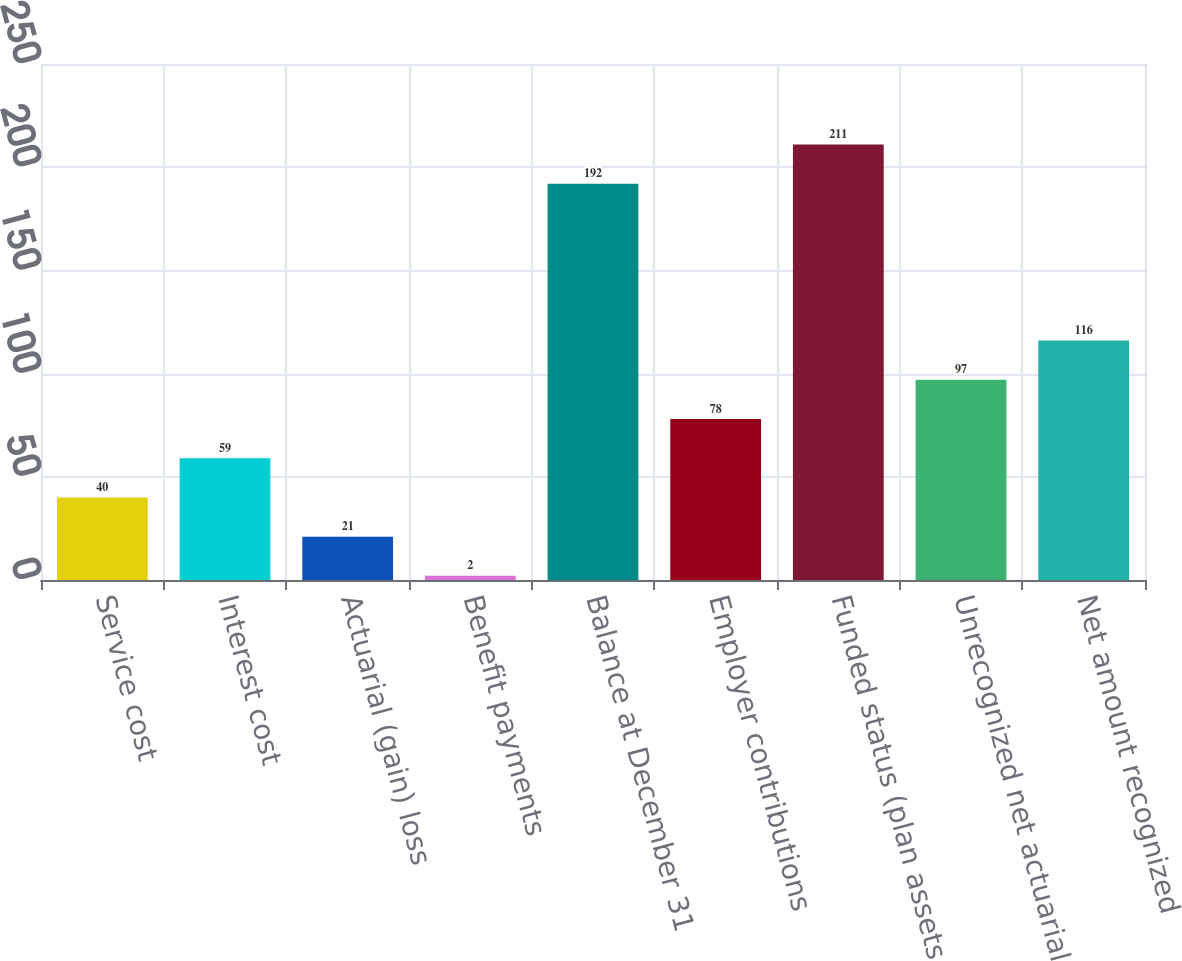Convert chart to OTSL. <chart><loc_0><loc_0><loc_500><loc_500><bar_chart><fcel>Service cost<fcel>Interest cost<fcel>Actuarial (gain) loss<fcel>Benefit payments<fcel>Balance at December 31<fcel>Employer contributions<fcel>Funded status (plan assets<fcel>Unrecognized net actuarial<fcel>Net amount recognized<nl><fcel>40<fcel>59<fcel>21<fcel>2<fcel>192<fcel>78<fcel>211<fcel>97<fcel>116<nl></chart> 